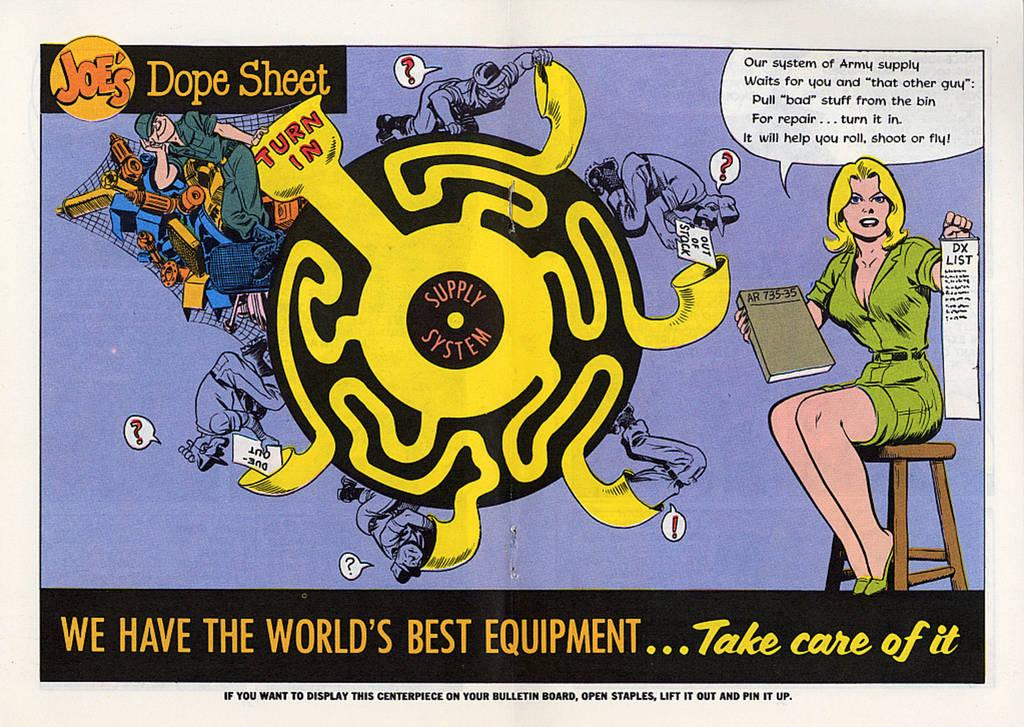<image>
Provide a brief description of the given image. An brightly colored advertisement with a woman wearing a green dress saying We have the World's Best Equipment...Take Care of it. 